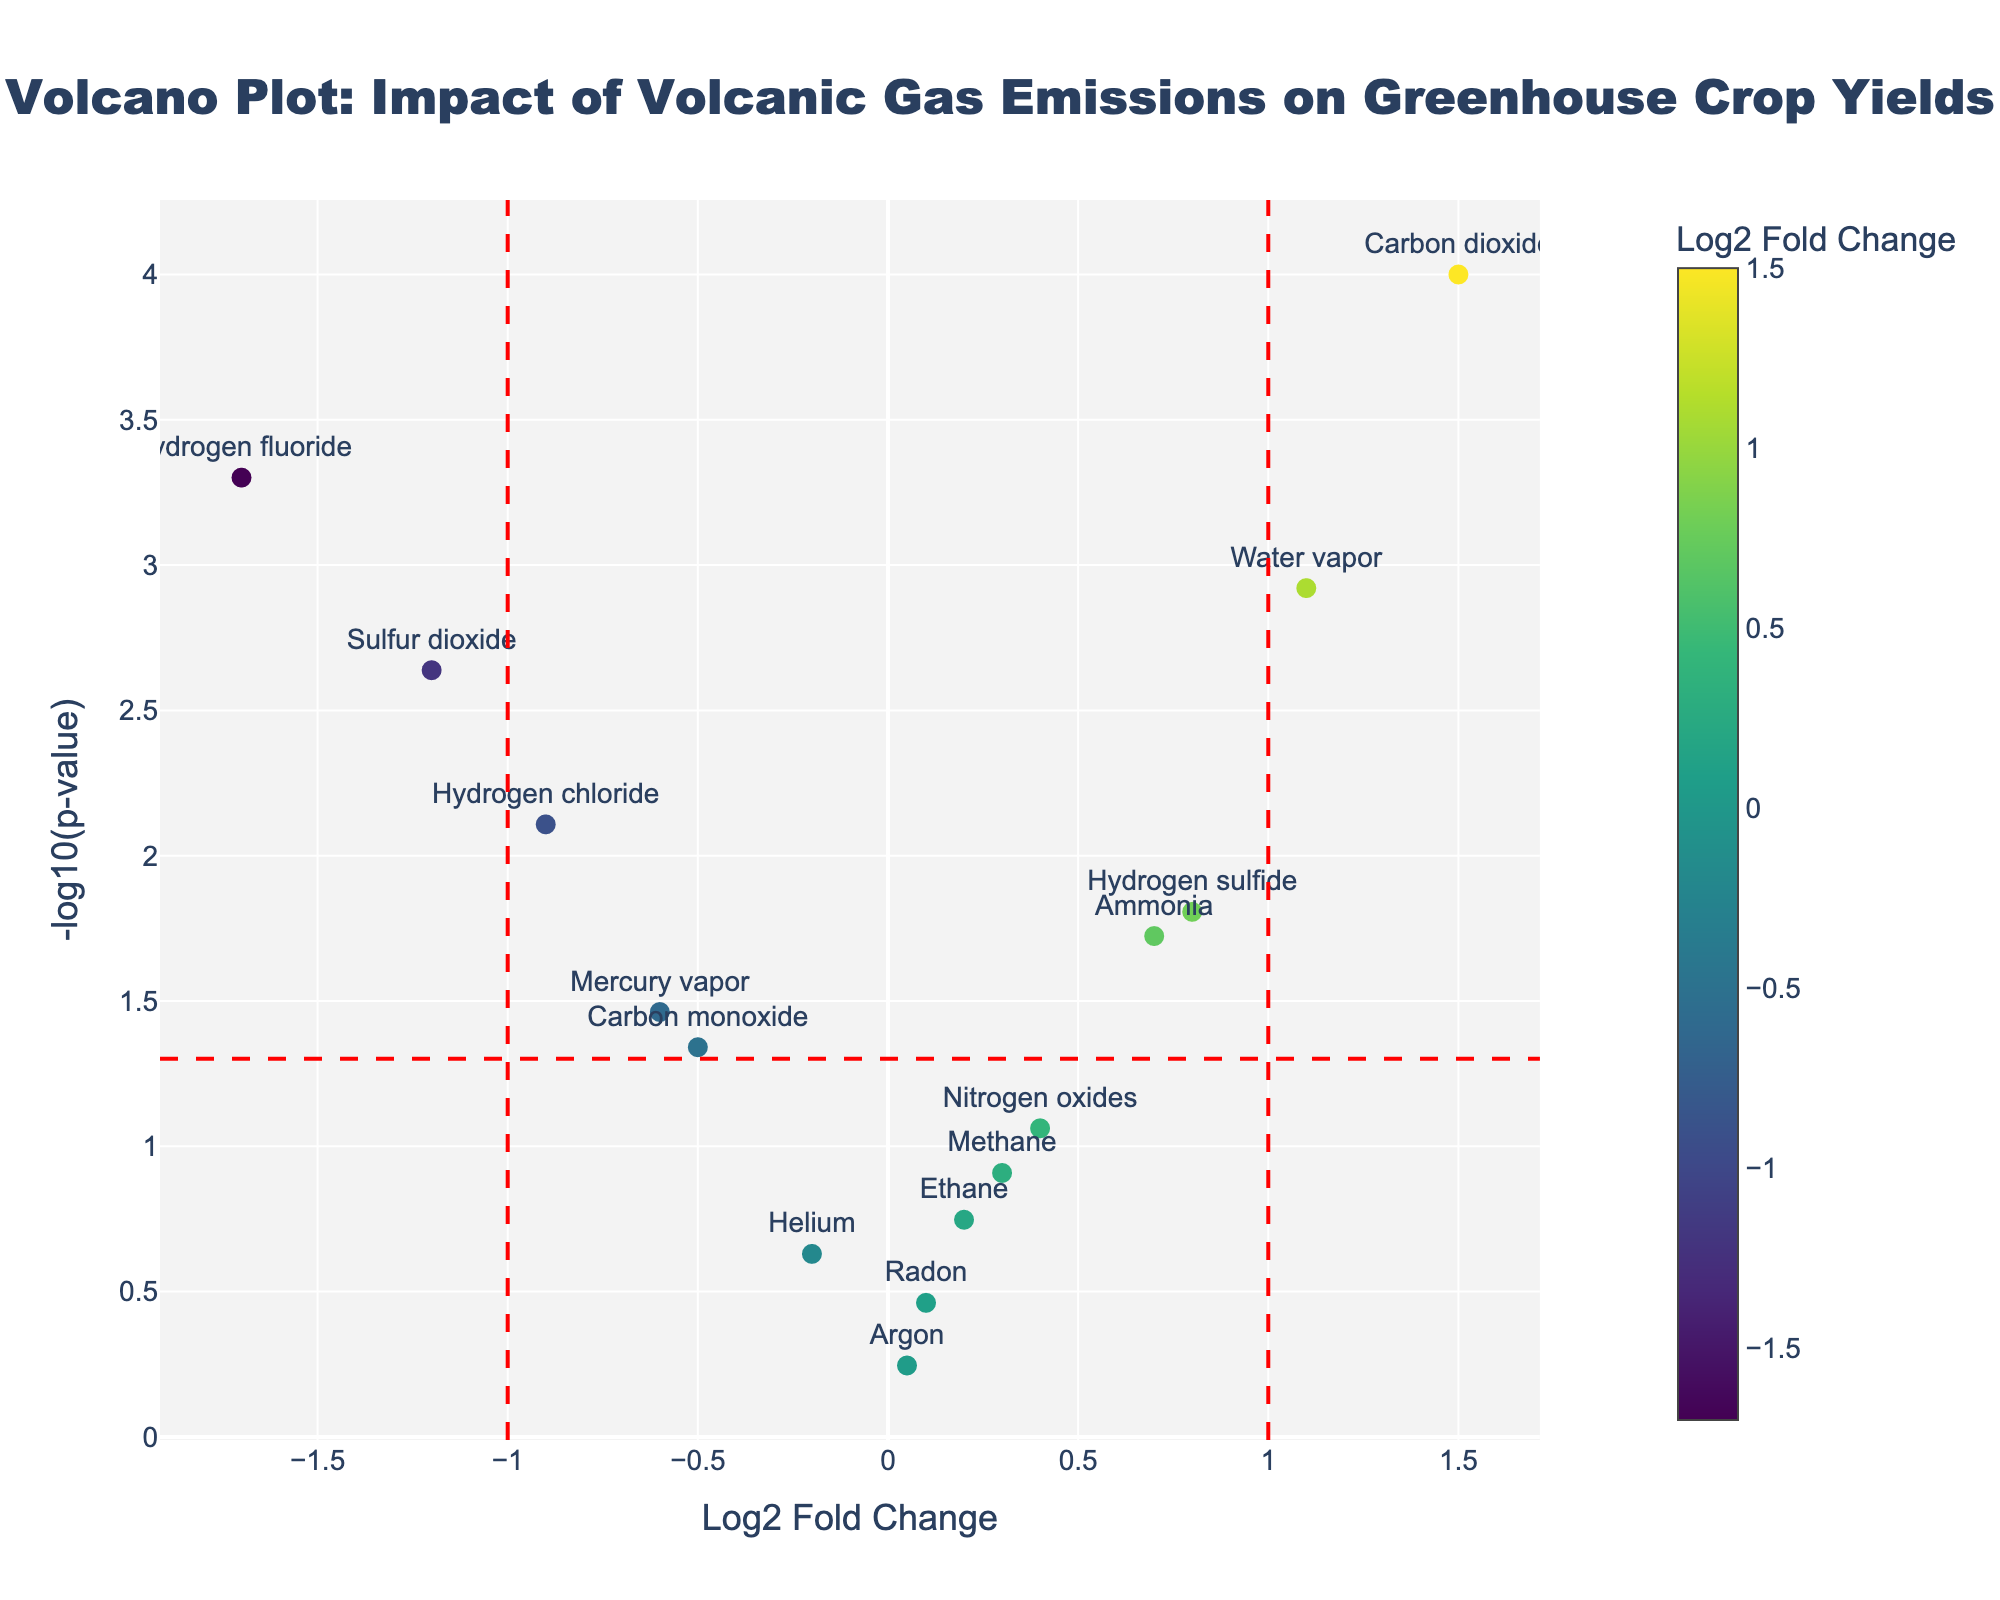What is the high-level purpose of this Volcano Plot? The high-level purpose of this Volcano Plot is to illustrate the impact of volcanic gas emissions on greenhouse crop yields near geothermal sites by showing which compounds are statistically significant (low p-value) and have a substantial effect (high log2 fold change). The title of the plot provides these details directly.
Answer: To illustrate the impact of volcanic gas emissions on greenhouse crop yields How many compounds have a log2 fold change greater than 1 or less than -1? From the plot, we count the number of data points (compounds) with a Log2 Fold Change > 1 or < -1. There are 3 compounds with log2 fold change > 1 (Carbon dioxide and Water vapor) and 2 compounds with log2 fold change < -1 (Sulfur dioxide, Hydrogen chloride, and Hydrogen fluoride).
Answer: 5 Which compound has the lowest p-value, and what is its log2 fold change? Identify the compound that is furthest along the y-axis (i.e., highest -log10(p)). From the data, Carbon dioxide has the lowest p-value and its log2 fold change is 1.5.
Answer: Carbon dioxide, 1.5 Are there any compounds that have a relatively low impact on greenhouse crop yields but are still statistically significant? Look for points that are close to 0 on the x-axis (log2 fold change) but situated above the horizontal threshold line indicating significance (-log10(p) > 1.301). Methane and Ammonia have relatively low impacts (log2 fold change close to 0) but are statistically significant. Both plot near the y-axis yet above the threshold line.
Answer: Methane and Ammonia How does the amount of statistically significant compounds compare to non-significant compounds? Count the points above the horizontal significance threshold line and compare with those below it. There are 9 statistically significant compounds (above the red horizontal line indicating -log10(0.05)), and 6 non-significant compounds (below the line).
Answer: 9 significant, 6 non-significant Which side of the plot shows compounds that negatively impact crop yields? Compounds with a negative impact on crop yields are those with a negative log2 fold change (left side of the plot).
Answer: Left side 